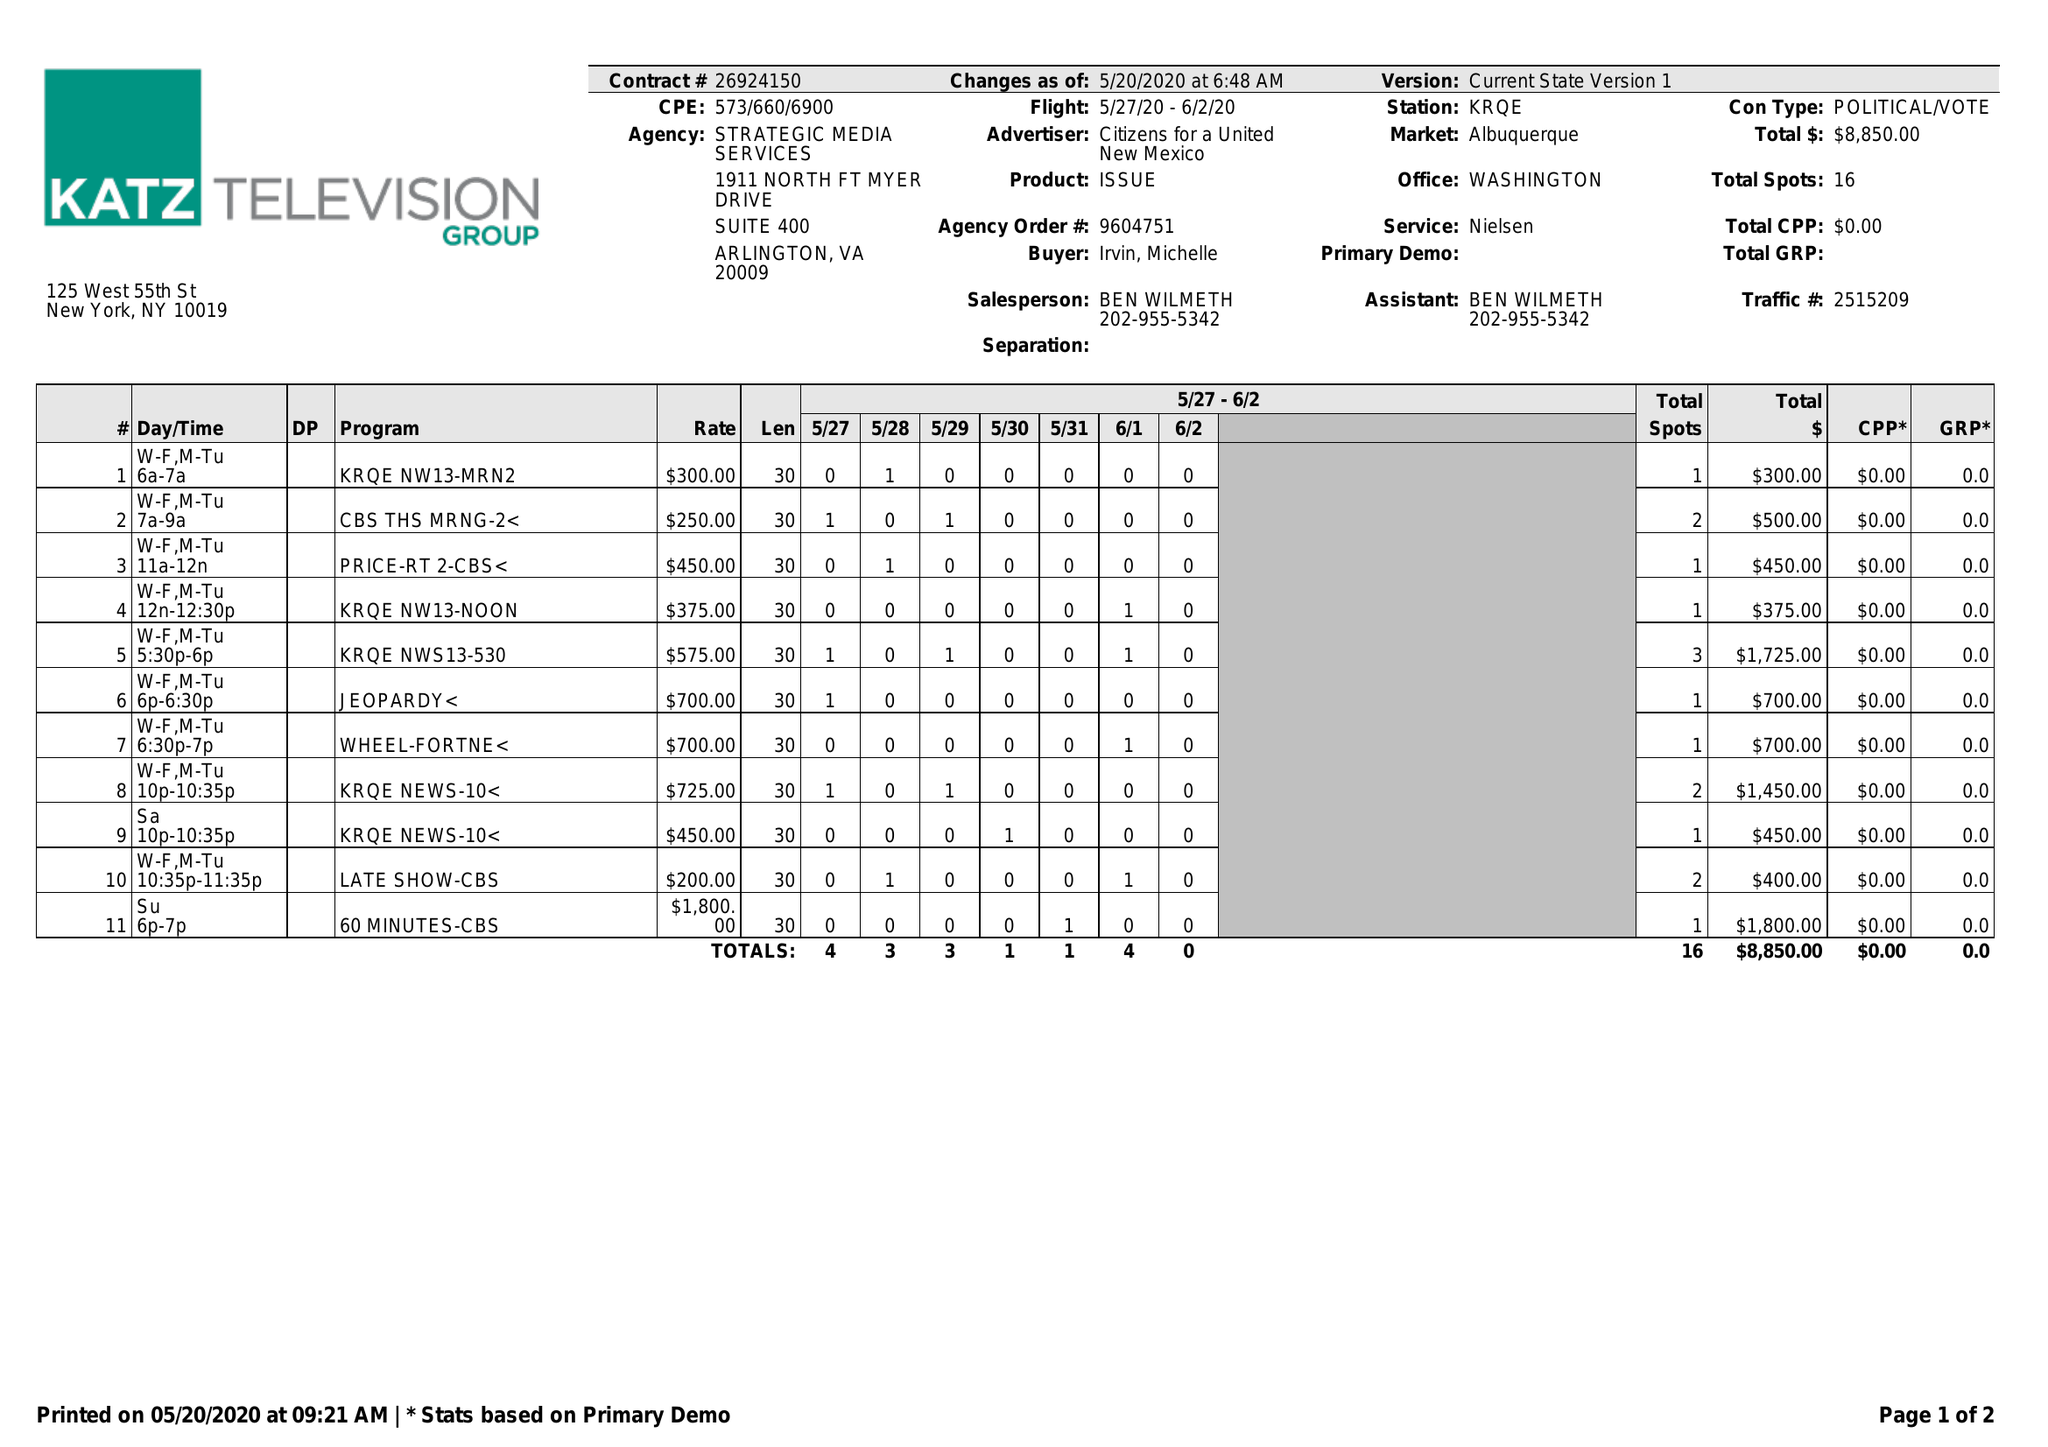What is the value for the gross_amount?
Answer the question using a single word or phrase. 8850.00 